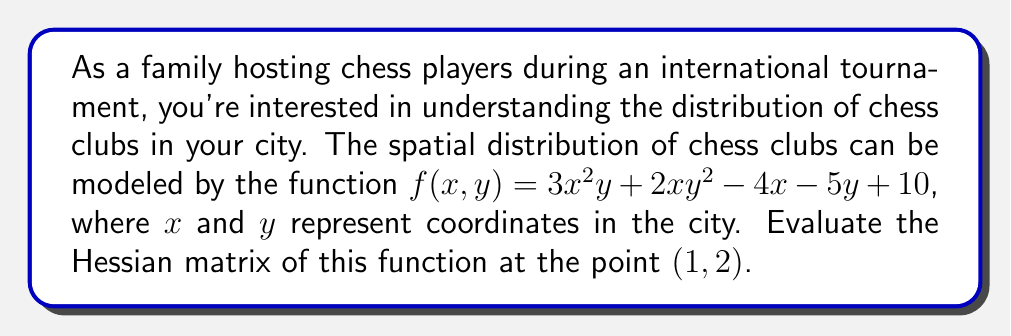Solve this math problem. To evaluate the Hessian matrix, we need to follow these steps:

1) The Hessian matrix is defined as:

   $$H = \begin{bmatrix}
   \frac{\partial^2f}{\partial x^2} & \frac{\partial^2f}{\partial x\partial y} \\
   \frac{\partial^2f}{\partial y\partial x} & \frac{\partial^2f}{\partial y^2}
   \end{bmatrix}$$

2) Let's calculate each second partial derivative:

   a) $\frac{\partial f}{\partial x} = 6xy + 2y^2 - 4$
      $\frac{\partial^2f}{\partial x^2} = 6y$

   b) $\frac{\partial f}{\partial y} = 3x^2 + 4xy - 5$
      $\frac{\partial^2f}{\partial y^2} = 4x$

   c) $\frac{\partial^2f}{\partial x\partial y} = \frac{\partial^2f}{\partial y\partial x} = 6x + 4y$

3) Now, we can form the Hessian matrix:

   $$H = \begin{bmatrix}
   6y & 6x + 4y \\
   6x + 4y & 4x
   \end{bmatrix}$$

4) Evaluate the Hessian at the point $(1,2)$:

   $$H_{(1,2)} = \begin{bmatrix}
   6(2) & 6(1) + 4(2) \\
   6(1) + 4(2) & 4(1)
   \end{bmatrix} = \begin{bmatrix}
   12 & 14 \\
   14 & 4
   \end{bmatrix}$$
Answer: $$\begin{bmatrix}
12 & 14 \\
14 & 4
\end{bmatrix}$$ 